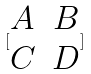Convert formula to latex. <formula><loc_0><loc_0><loc_500><loc_500>[ \begin{matrix} A & B \\ C & D \end{matrix} ]</formula> 